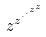Convert formula to latex. <formula><loc_0><loc_0><loc_500><loc_500>z ^ { z ^ { \cdot ^ { \cdot ^ { z ^ { z } } } } }</formula> 